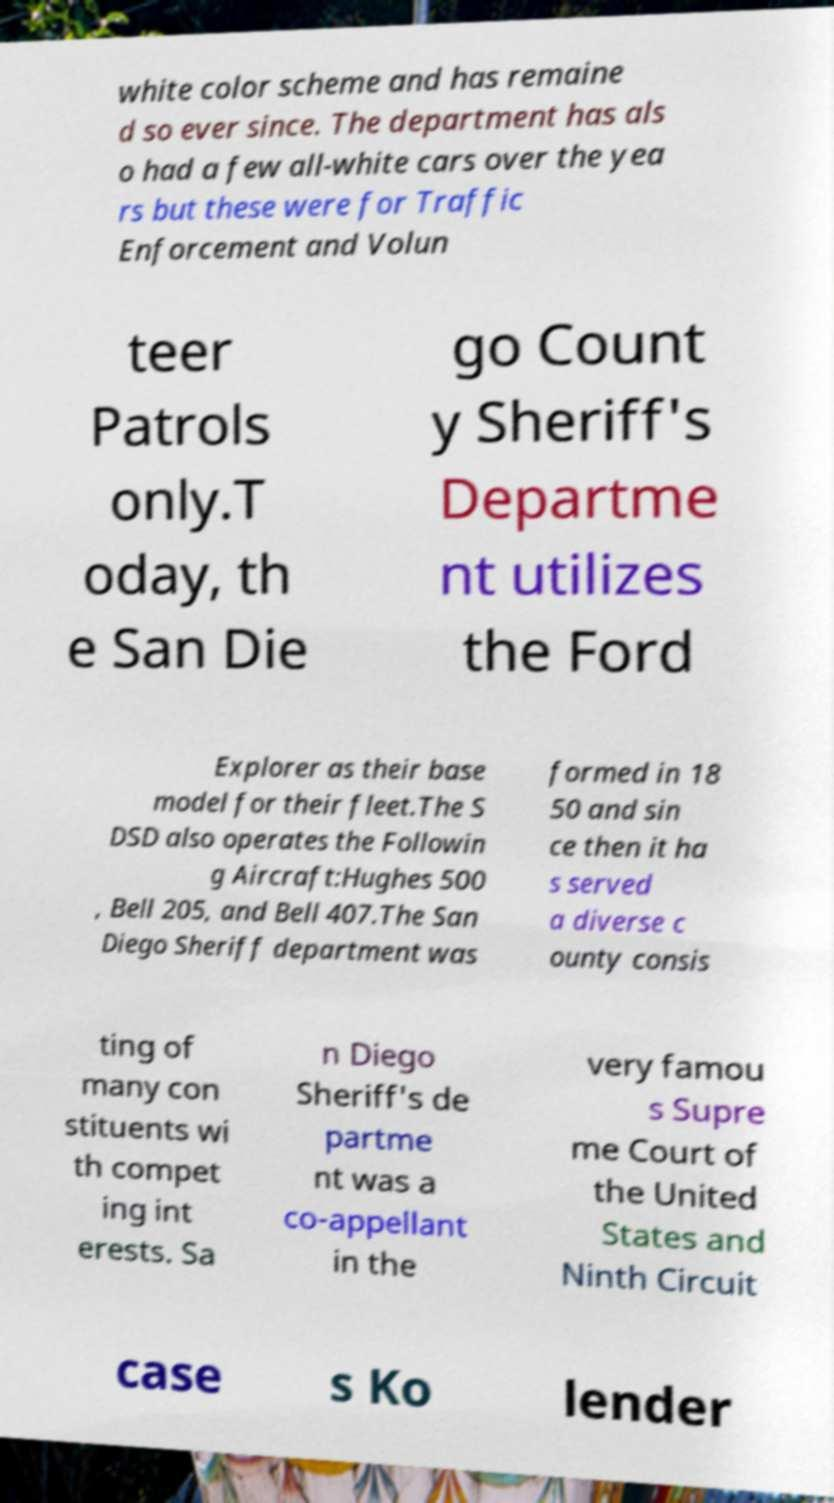Can you accurately transcribe the text from the provided image for me? white color scheme and has remaine d so ever since. The department has als o had a few all-white cars over the yea rs but these were for Traffic Enforcement and Volun teer Patrols only.T oday, th e San Die go Count y Sheriff's Departme nt utilizes the Ford Explorer as their base model for their fleet.The S DSD also operates the Followin g Aircraft:Hughes 500 , Bell 205, and Bell 407.The San Diego Sheriff department was formed in 18 50 and sin ce then it ha s served a diverse c ounty consis ting of many con stituents wi th compet ing int erests. Sa n Diego Sheriff's de partme nt was a co-appellant in the very famou s Supre me Court of the United States and Ninth Circuit case s Ko lender 